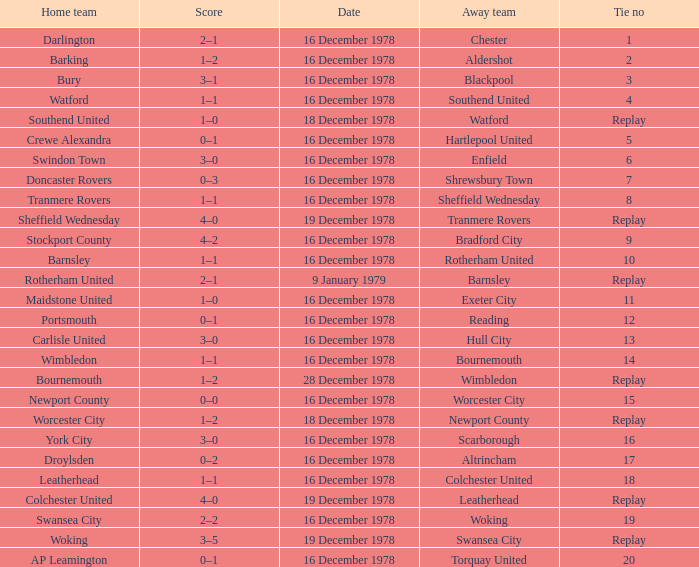Waht was the away team when the home team is colchester united? Leatherhead. 